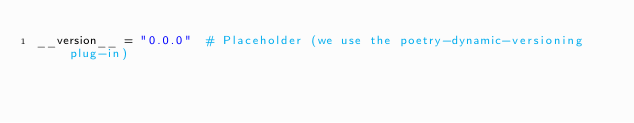<code> <loc_0><loc_0><loc_500><loc_500><_Python_>__version__ = "0.0.0"  # Placeholder (we use the poetry-dynamic-versioning plug-in)
</code> 